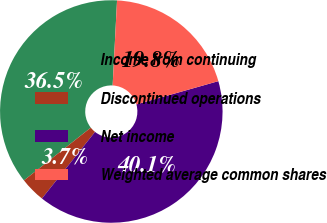<chart> <loc_0><loc_0><loc_500><loc_500><pie_chart><fcel>Income from continuing<fcel>Discontinued operations<fcel>Net income<fcel>Weighted average common shares<nl><fcel>36.45%<fcel>3.66%<fcel>40.11%<fcel>19.78%<nl></chart> 